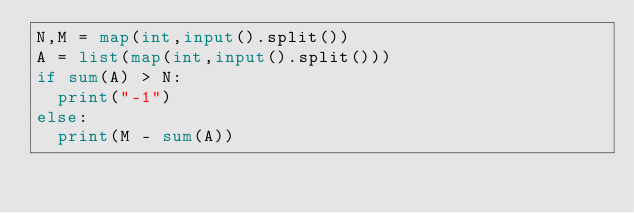Convert code to text. <code><loc_0><loc_0><loc_500><loc_500><_Python_>N,M = map(int,input().split())
A = list(map(int,input().split()))
if sum(A) > N:
  print("-1")
else:
  print(M - sum(A))</code> 